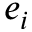Convert formula to latex. <formula><loc_0><loc_0><loc_500><loc_500>e _ { i }</formula> 